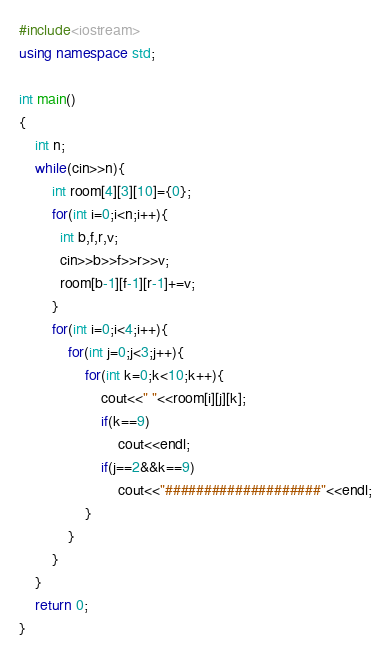<code> <loc_0><loc_0><loc_500><loc_500><_C++_>#include<iostream>
using namespace std;

int main()
{
    int n;
    while(cin>>n){
        int room[4][3][10]={0};
        for(int i=0;i<n;i++){
          int b,f,r,v;
          cin>>b>>f>>r>>v;
          room[b-1][f-1][r-1]+=v;
        }
        for(int i=0;i<4;i++){
            for(int j=0;j<3;j++){
                for(int k=0;k<10;k++){
                    cout<<" "<<room[i][j][k];
                    if(k==9)
                        cout<<endl;
                    if(j==2&&k==9)
                        cout<<"####################"<<endl;
                }
            }
        }
    }
    return 0;
}</code> 